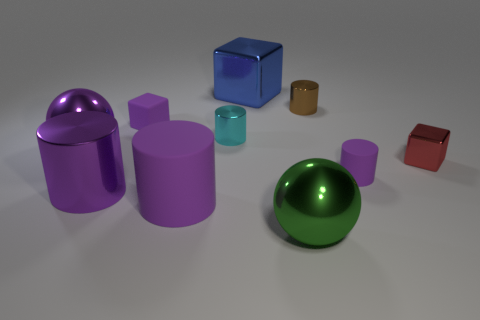How many purple cylinders must be subtracted to get 1 purple cylinders? 2 Subtract all yellow spheres. How many purple cylinders are left? 3 Subtract all red cylinders. Subtract all yellow spheres. How many cylinders are left? 5 Subtract all blocks. How many objects are left? 7 Subtract 0 green cubes. How many objects are left? 10 Subtract all tiny cyan metal things. Subtract all small matte cubes. How many objects are left? 8 Add 5 cylinders. How many cylinders are left? 10 Add 8 tiny red metallic blocks. How many tiny red metallic blocks exist? 9 